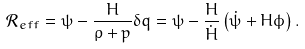Convert formula to latex. <formula><loc_0><loc_0><loc_500><loc_500>\mathcal { R } _ { e f f } = \psi - \frac { H } { \rho + p } \delta q = \psi - \frac { H } { \dot { H } } \left ( \dot { \psi } + H \phi \right ) . \\</formula> 